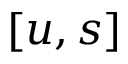Convert formula to latex. <formula><loc_0><loc_0><loc_500><loc_500>[ u , s ]</formula> 